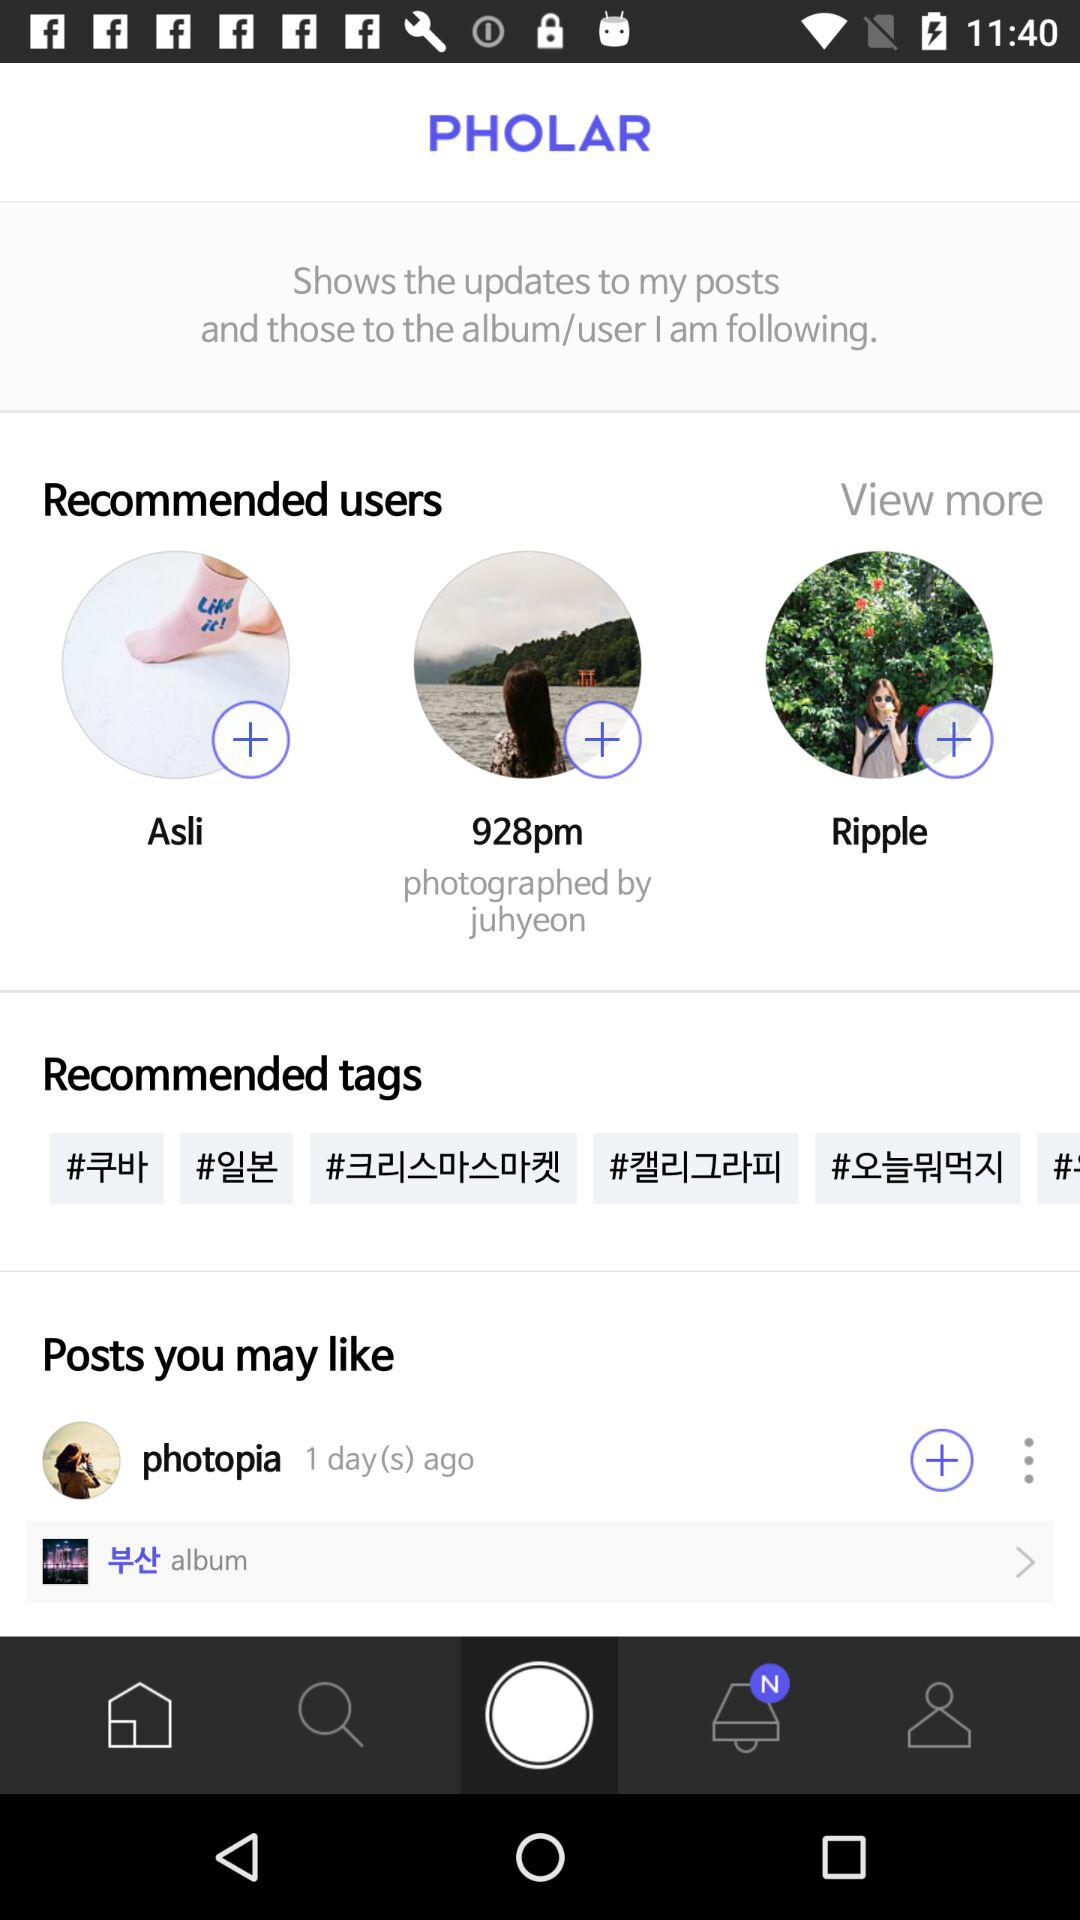Which photographer clicked the picture "928pm"? The picture "928pm" was clicked by "juhyeon". 